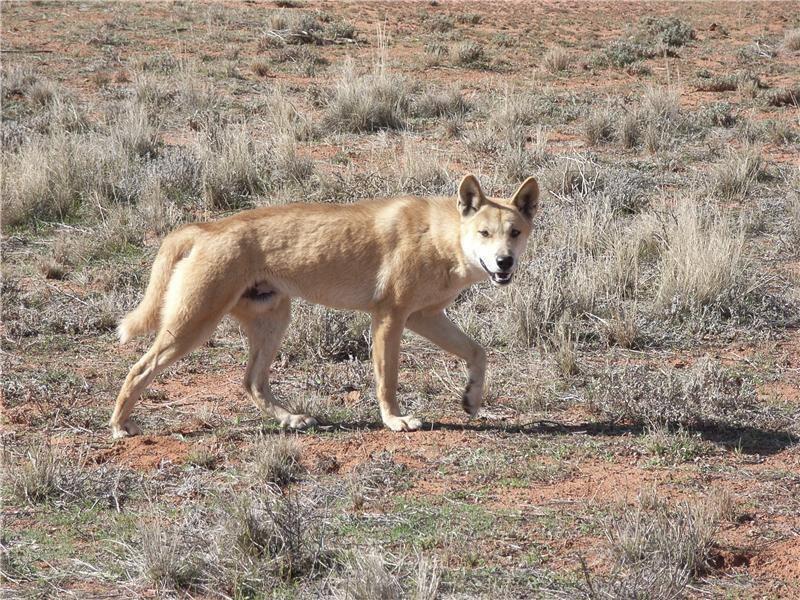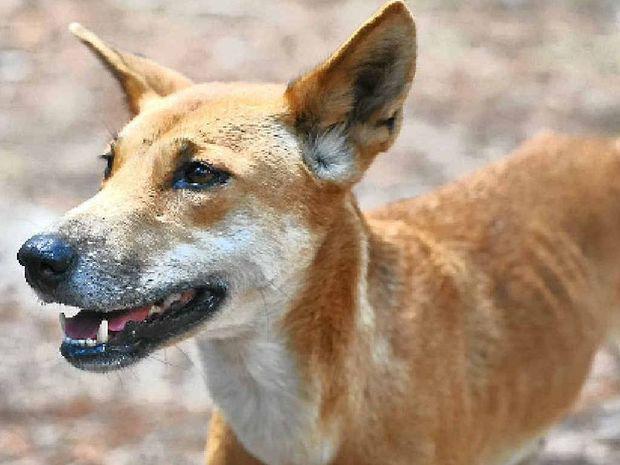The first image is the image on the left, the second image is the image on the right. For the images displayed, is the sentence "Each image shows only one wild dog, and the left image shows a dog with its body in profile turned rightward." factually correct? Answer yes or no. Yes. The first image is the image on the left, the second image is the image on the right. Evaluate the accuracy of this statement regarding the images: "At least one image shows a single dog and no dog in any image has its mouth open.". Is it true? Answer yes or no. No. 